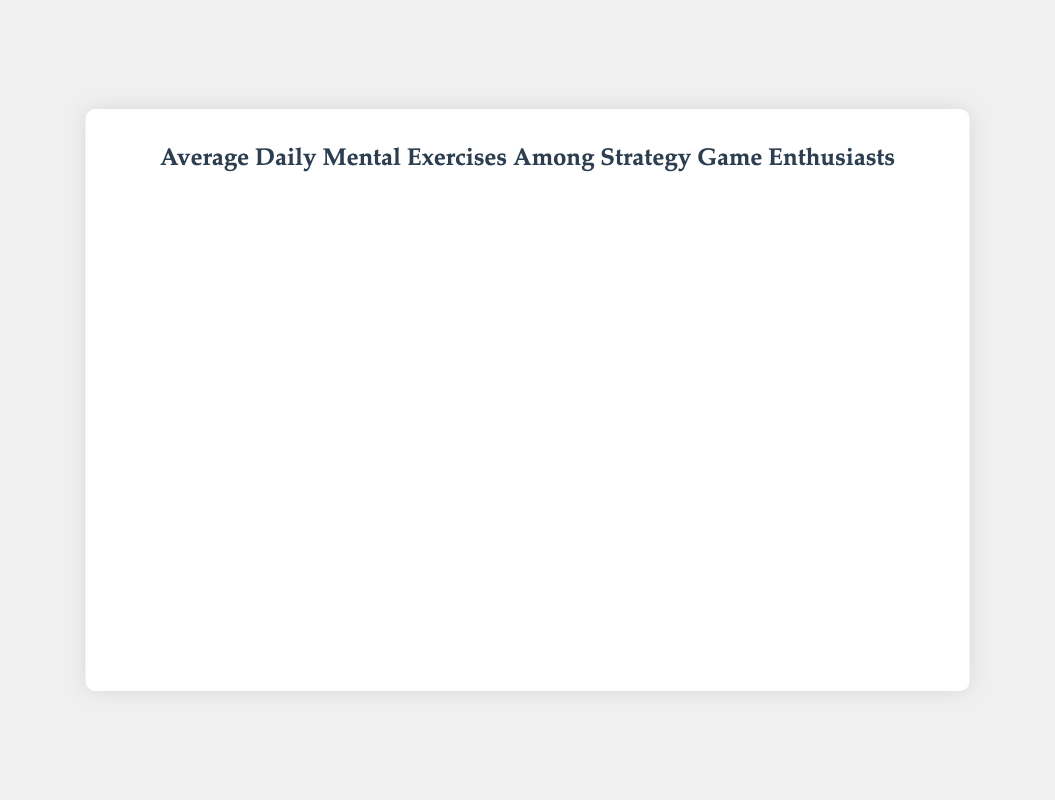Which group spends the most time on a single activity? Poker Players spend the most time on Live Play, with 30%. This is higher than any other single activity among the groups.
Answer: Poker Players Comparing Chess Masters and Bridge Players, which group spends more time on Puzzle Solving? Chess Masters spend 15% on Puzzle Solving while Bridge Players spend 10%. By comparing these values, Chess Masters spend more time on Puzzle Solving.
Answer: Chess Masters What is the total time spent on activities related to analysis by Chess Masters? For Chess Masters, Game Analysis is 25% and Endgame Practice is 10%. Summing these values gives 25 + 10 = 35%.
Answer: 35% Which two groups have the same percentage allocation for their top activity? Brazilian Jiu-Jitsu Practitioners spend 30% on General Fitness and Bridge Players spend 30% on both Bidding Practice and Hand Play Studies. Both groups allocate the same percentage to their top activity.
Answer: Brazilian Jiu-Jitsu Practitioners and Bridge Players How much more time do Go Players spend on Full Game Reviews compared to AI Analysis? Go Players spend 30% on Full Game Reviews and 10% on AI Analysis. The difference is 30 - 10 = 20%.
Answer: 20% Which group has the most diverse range of activities (least concentration in one activity)? Brazilian Jiu-Jitsu Practitioners have the lowest percentage in their top activity (30% for General Fitness), indicating a more balanced distribution across different activities.
Answer: Brazilian Jiu-Jitsu Practitioners Identify the group with the highest total time spent on live or real-time activities. Poker Players spend 30% on Live Play. Summing live-related activities for other groups: Go Players (Live Play 25%), Chess Masters (Blitz Games 15%), Strategic Video Gamers (Live Streams 15%), Bridge Players (none directly related). Poker Players have the highest total.
Answer: Poker Players What is the combined time spent on Strategy Sessions and Sparring Analysis by Brazilian Jiu-Jitsu Practitioners? Brazilian Jiu-Jitsu Practitioners spend 20% on Strategy Sessions and 20% on Sparring Analysis. The combined time is 20 + 20 = 40%.
Answer: 40% Which group spends the least time on a non-strategy activity? Comparing minimum times across groups, Brazilian Jiu-Jitsu Practitioners allocate 10% to Meditation, which is the least time spent on a non-strategy activity.
Answer: Brazilian Jiu-Jitsu Practitioners 